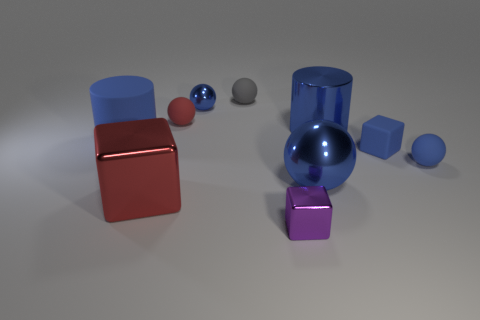There is a blue cylinder that is the same material as the gray sphere; what is its size?
Offer a very short reply. Large. There is a red thing that is in front of the blue rubber block; what is its shape?
Offer a terse response. Cube. What size is the red object that is the same shape as the tiny purple thing?
Your response must be concise. Large. How many big objects are right of the sphere that is in front of the small blue ball that is in front of the big matte thing?
Make the answer very short. 1. Are there the same number of blue metal objects that are behind the large red object and small shiny things?
Your answer should be compact. No. How many spheres are blue rubber objects or rubber objects?
Keep it short and to the point. 3. Do the large matte object and the tiny shiny sphere have the same color?
Provide a short and direct response. Yes. Are there an equal number of big blue cylinders that are behind the tiny gray matte ball and big balls in front of the red matte sphere?
Keep it short and to the point. No. What color is the big block?
Give a very brief answer. Red. How many things are either tiny matte spheres on the left side of the blue metallic cylinder or small blue matte spheres?
Your answer should be compact. 3. 